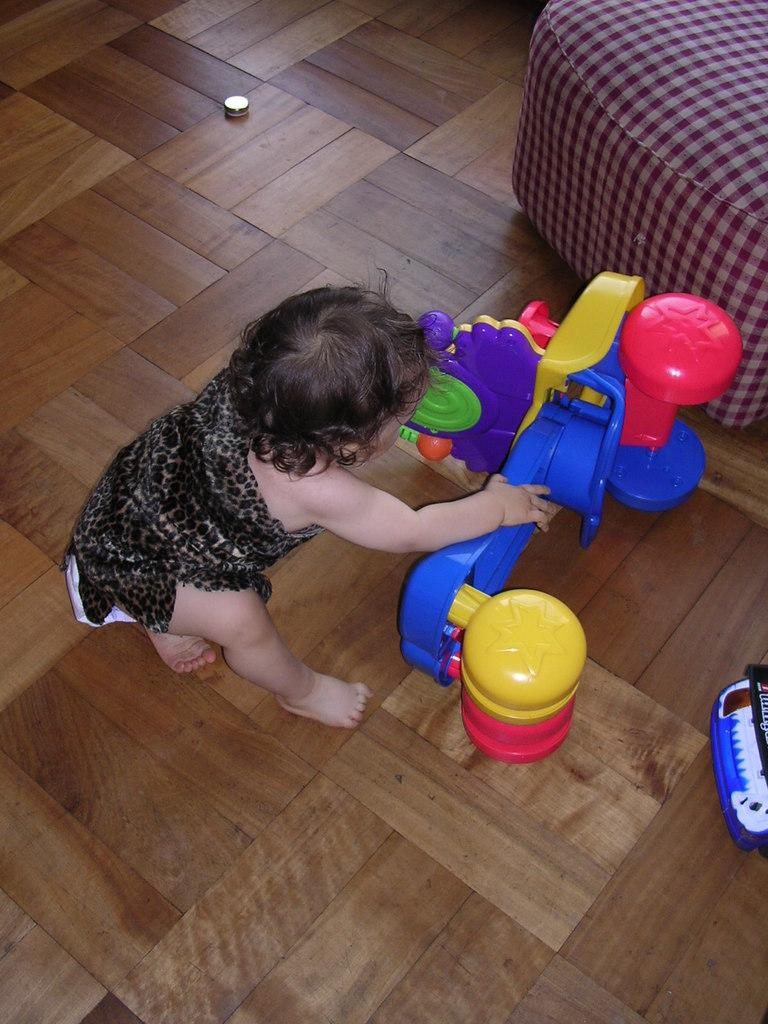What is the main subject of the image? The main subject of the image is a kid. Where is the kid located in the image? The kid is sitting on the wooden floor. What is the kid doing in the image? The kid is playing with a toy. What type of furniture can be seen in the image? There is a sofa on the right side of the image. How is the sofa positioned in the image? The sofa is located at the top of the image. What type of cap can be seen on the snails in the image? There are no snails or caps present in the image. How is the yarn being used by the kid in the image? There is no yarn visible in the image; the kid is playing with a toy. 